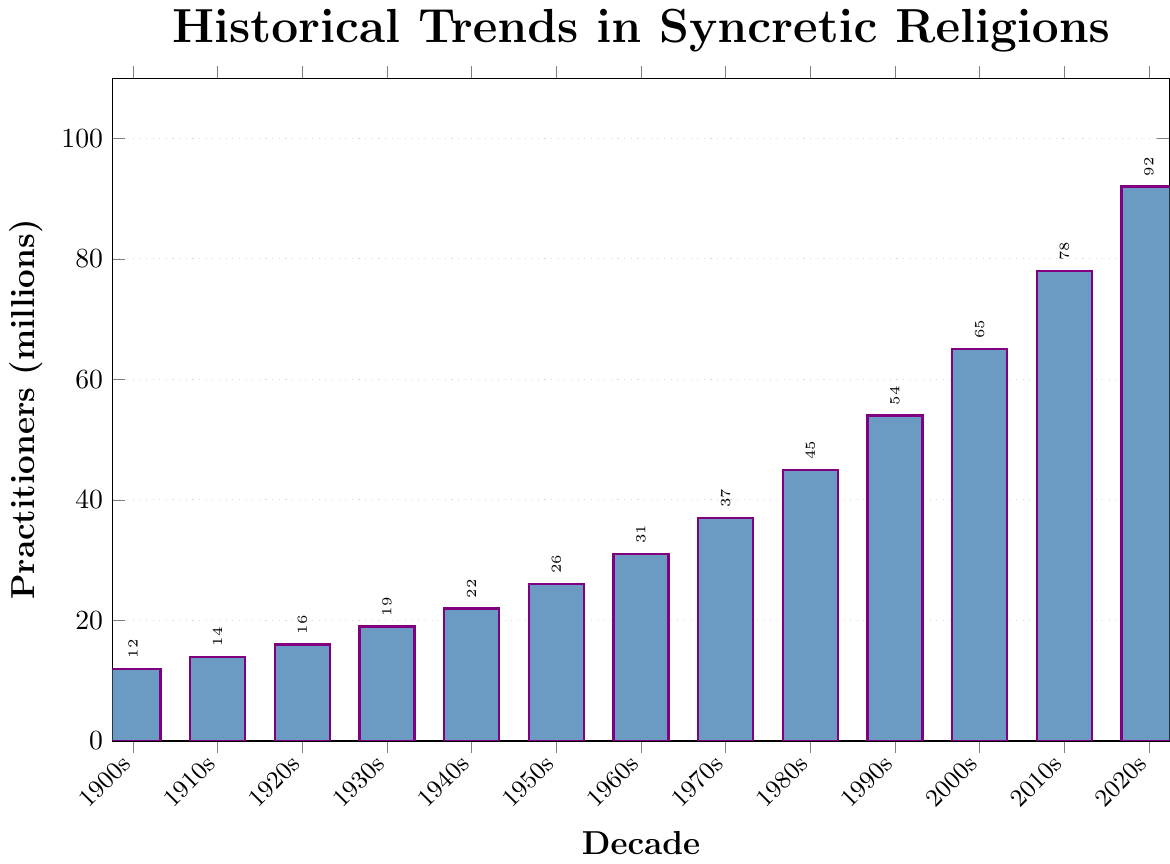what is the trend in the number of practitioners from 1900s to 2020s? To understand the trend, we look at the overall direction of the bars from left (1900s) to right (2020s). The bars steadily increase in height, showing that the number of practitioners rises over each decade.
Answer: Increasing how many practitioners were there in 1930s and 1950s combined? According to the figure, the 1930s had 19 million practitioners and the 1950s had 26 million. Adding these together gives 19 + 26 = 45 million.
Answer: 45 million was the increase in practitioners from the 2000s to the 2020s greater than from the 1900s to the 1920s? For the 2000s to 2020s, the increase is 92 - 65 = 27 million. For the 1900s to 1920s, the increase is 16 - 12 = 4 million. 27 million is greater than 4 million, so the increase from the 2000s to the 2020s was indeed greater.
Answer: Yes which decade had the highest number of practitioners? By comparing the heights of all the bars visually, the tallest bar corresponds to the 2020s, which had the highest number of practitioners.
Answer: 2020s how did the number of practitioners change from 1960s to 1980s? To find the change, look at the heights of the bars for the 1960s (31 million) and 1980s (45 million). The difference is 45 - 31 = 14 million, indicating an increase of 14 million.
Answer: Increased by 14 million what decade saw the smallest growth compared to the previous decade? To find the smallest growth, calculate the difference for each decade and compare. The smallest difference is between the 1900s (12 million) and 1910s (14 million), which is 14 - 12 = 2 million.
Answer: 1910s how many practitioners were there on average in the first five decades (1900s-1940s)? Calculate the sum for 1900s(12 million), 1910s(14 million), 1920s(16 million), 1930s(19 million), and 1940s(22 million), then divide by 5. The sum is 12 + 14 + 16 + 19 + 22 = 83 million. The average is 83 / 5 = 16.6 million.
Answer: 16.6 million compare the growth in practitioners between the 1960s to 1970s and the 1980s to 1990s For 1960s to 1970s, the growth is 37 - 31 = 6 million. For 1980s to 1990s, the growth is 54 - 45 = 9 million. 9 million is greater than 6 million, so the growth from the 1980s to 1990s was greater.
Answer: The growth between the 1980s to 1990s was greater which decade had the most significant percentage increase in practitioners over the previous decade? Calculate the percentage increase for each decade using (new - old) / old * 100%. The highest percentage increase is between the 1900s (12 million) and 1910s (14 million) = (14 - 12) / 12 * 100% = 16.67%.
Answer: 1910s (16.67%) 